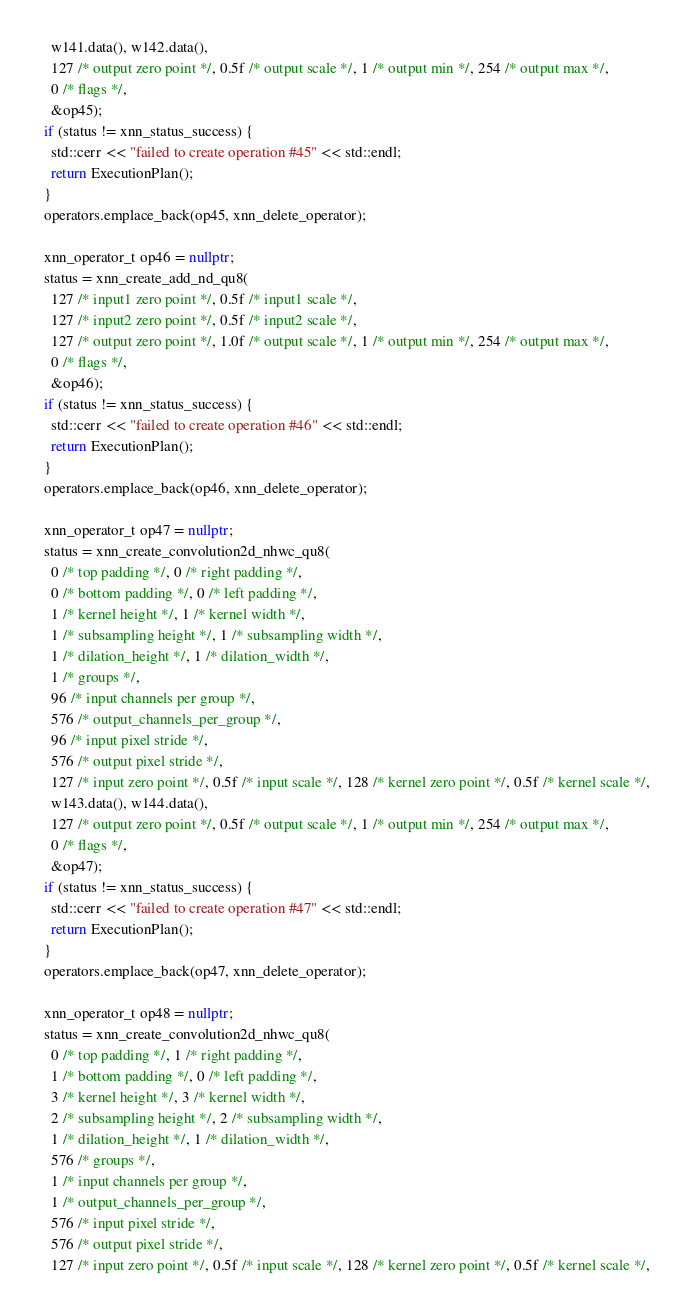Convert code to text. <code><loc_0><loc_0><loc_500><loc_500><_C++_>    w141.data(), w142.data(),
    127 /* output zero point */, 0.5f /* output scale */, 1 /* output min */, 254 /* output max */,
    0 /* flags */,
    &op45);
  if (status != xnn_status_success) {
    std::cerr << "failed to create operation #45" << std::endl;
    return ExecutionPlan();
  }
  operators.emplace_back(op45, xnn_delete_operator);

  xnn_operator_t op46 = nullptr;
  status = xnn_create_add_nd_qu8(
    127 /* input1 zero point */, 0.5f /* input1 scale */,
    127 /* input2 zero point */, 0.5f /* input2 scale */,
    127 /* output zero point */, 1.0f /* output scale */, 1 /* output min */, 254 /* output max */,
    0 /* flags */,
    &op46);
  if (status != xnn_status_success) {
    std::cerr << "failed to create operation #46" << std::endl;
    return ExecutionPlan();
  }
  operators.emplace_back(op46, xnn_delete_operator);

  xnn_operator_t op47 = nullptr;
  status = xnn_create_convolution2d_nhwc_qu8(
    0 /* top padding */, 0 /* right padding */,
    0 /* bottom padding */, 0 /* left padding */,
    1 /* kernel height */, 1 /* kernel width */,
    1 /* subsampling height */, 1 /* subsampling width */,
    1 /* dilation_height */, 1 /* dilation_width */,
    1 /* groups */,
    96 /* input channels per group */,
    576 /* output_channels_per_group */,
    96 /* input pixel stride */,
    576 /* output pixel stride */,
    127 /* input zero point */, 0.5f /* input scale */, 128 /* kernel zero point */, 0.5f /* kernel scale */,
    w143.data(), w144.data(),
    127 /* output zero point */, 0.5f /* output scale */, 1 /* output min */, 254 /* output max */,
    0 /* flags */,
    &op47);
  if (status != xnn_status_success) {
    std::cerr << "failed to create operation #47" << std::endl;
    return ExecutionPlan();
  }
  operators.emplace_back(op47, xnn_delete_operator);

  xnn_operator_t op48 = nullptr;
  status = xnn_create_convolution2d_nhwc_qu8(
    0 /* top padding */, 1 /* right padding */,
    1 /* bottom padding */, 0 /* left padding */,
    3 /* kernel height */, 3 /* kernel width */,
    2 /* subsampling height */, 2 /* subsampling width */,
    1 /* dilation_height */, 1 /* dilation_width */,
    576 /* groups */,
    1 /* input channels per group */,
    1 /* output_channels_per_group */,
    576 /* input pixel stride */,
    576 /* output pixel stride */,
    127 /* input zero point */, 0.5f /* input scale */, 128 /* kernel zero point */, 0.5f /* kernel scale */,</code> 